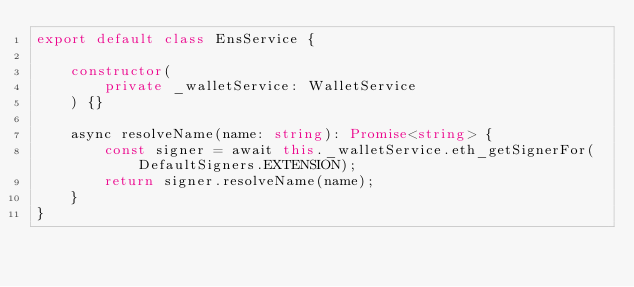Convert code to text. <code><loc_0><loc_0><loc_500><loc_500><_TypeScript_>export default class EnsService {

    constructor(
        private _walletService: WalletService
    ) {}

    async resolveName(name: string): Promise<string> {
        const signer = await this._walletService.eth_getSignerFor(DefaultSigners.EXTENSION);
        return signer.resolveName(name);
    }
}</code> 